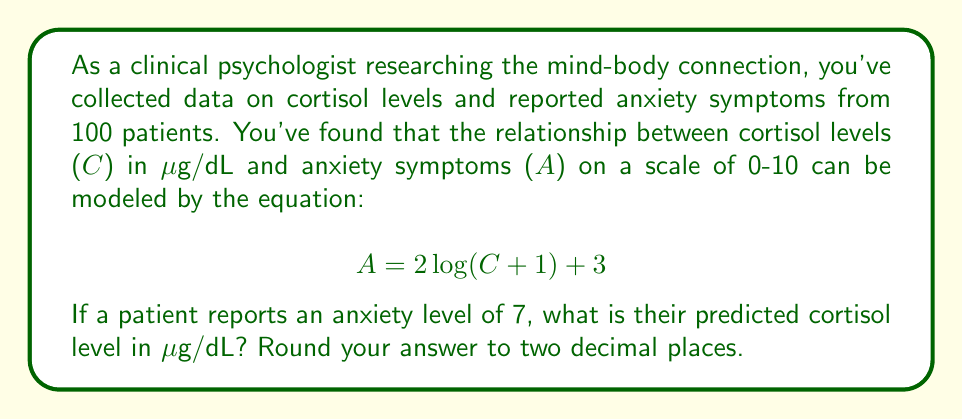Provide a solution to this math problem. To solve this problem, we need to work backwards from the given anxiety level to find the corresponding cortisol level. Let's approach this step-by-step:

1) We're given that $A = 7$. Let's substitute this into our equation:

   $$ 7 = 2\log(C + 1) + 3 $$

2) First, let's subtract 3 from both sides:

   $$ 4 = 2\log(C + 1) $$

3) Now, divide both sides by 2:

   $$ 2 = \log(C + 1) $$

4) To isolate C, we need to apply the inverse function of log (which is exponential) to both sides:

   $$ e^2 = C + 1 $$

5) Subtract 1 from both sides:

   $$ e^2 - 1 = C $$

6) Now we can calculate the value:

   $$ C = e^2 - 1 \approx 7.3891 - 1 = 6.3891 $$

7) Rounding to two decimal places:

   $$ C \approx 6.39 $$

Therefore, a patient reporting an anxiety level of 7 is predicted to have a cortisol level of approximately 6.39 μg/dL.
Answer: 6.39 μg/dL 